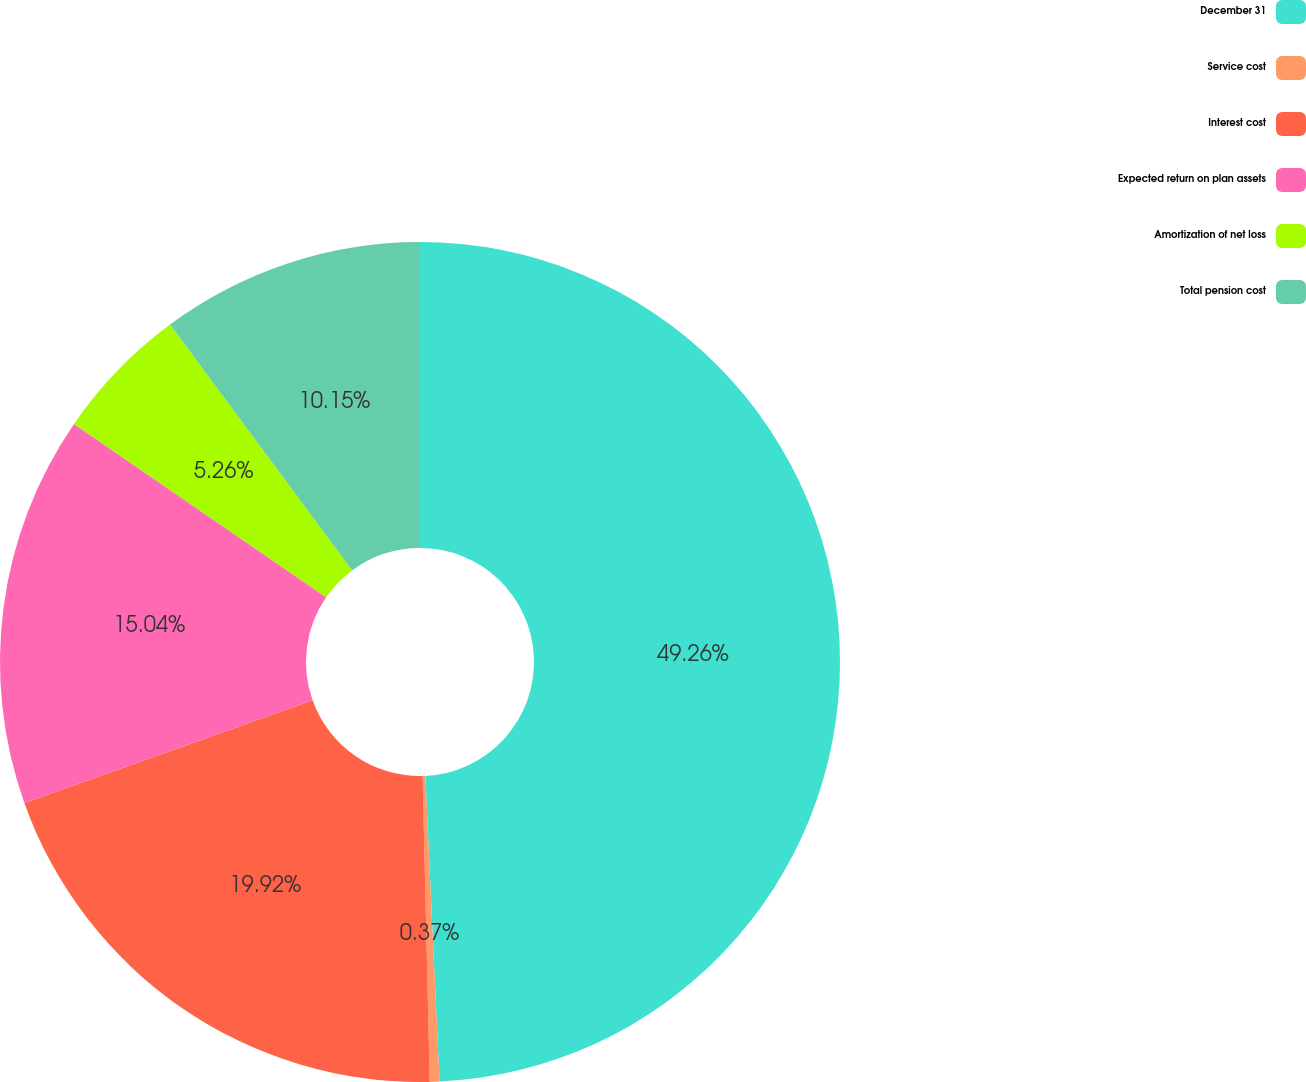Convert chart. <chart><loc_0><loc_0><loc_500><loc_500><pie_chart><fcel>December 31<fcel>Service cost<fcel>Interest cost<fcel>Expected return on plan assets<fcel>Amortization of net loss<fcel>Total pension cost<nl><fcel>49.27%<fcel>0.37%<fcel>19.93%<fcel>15.04%<fcel>5.26%<fcel>10.15%<nl></chart> 